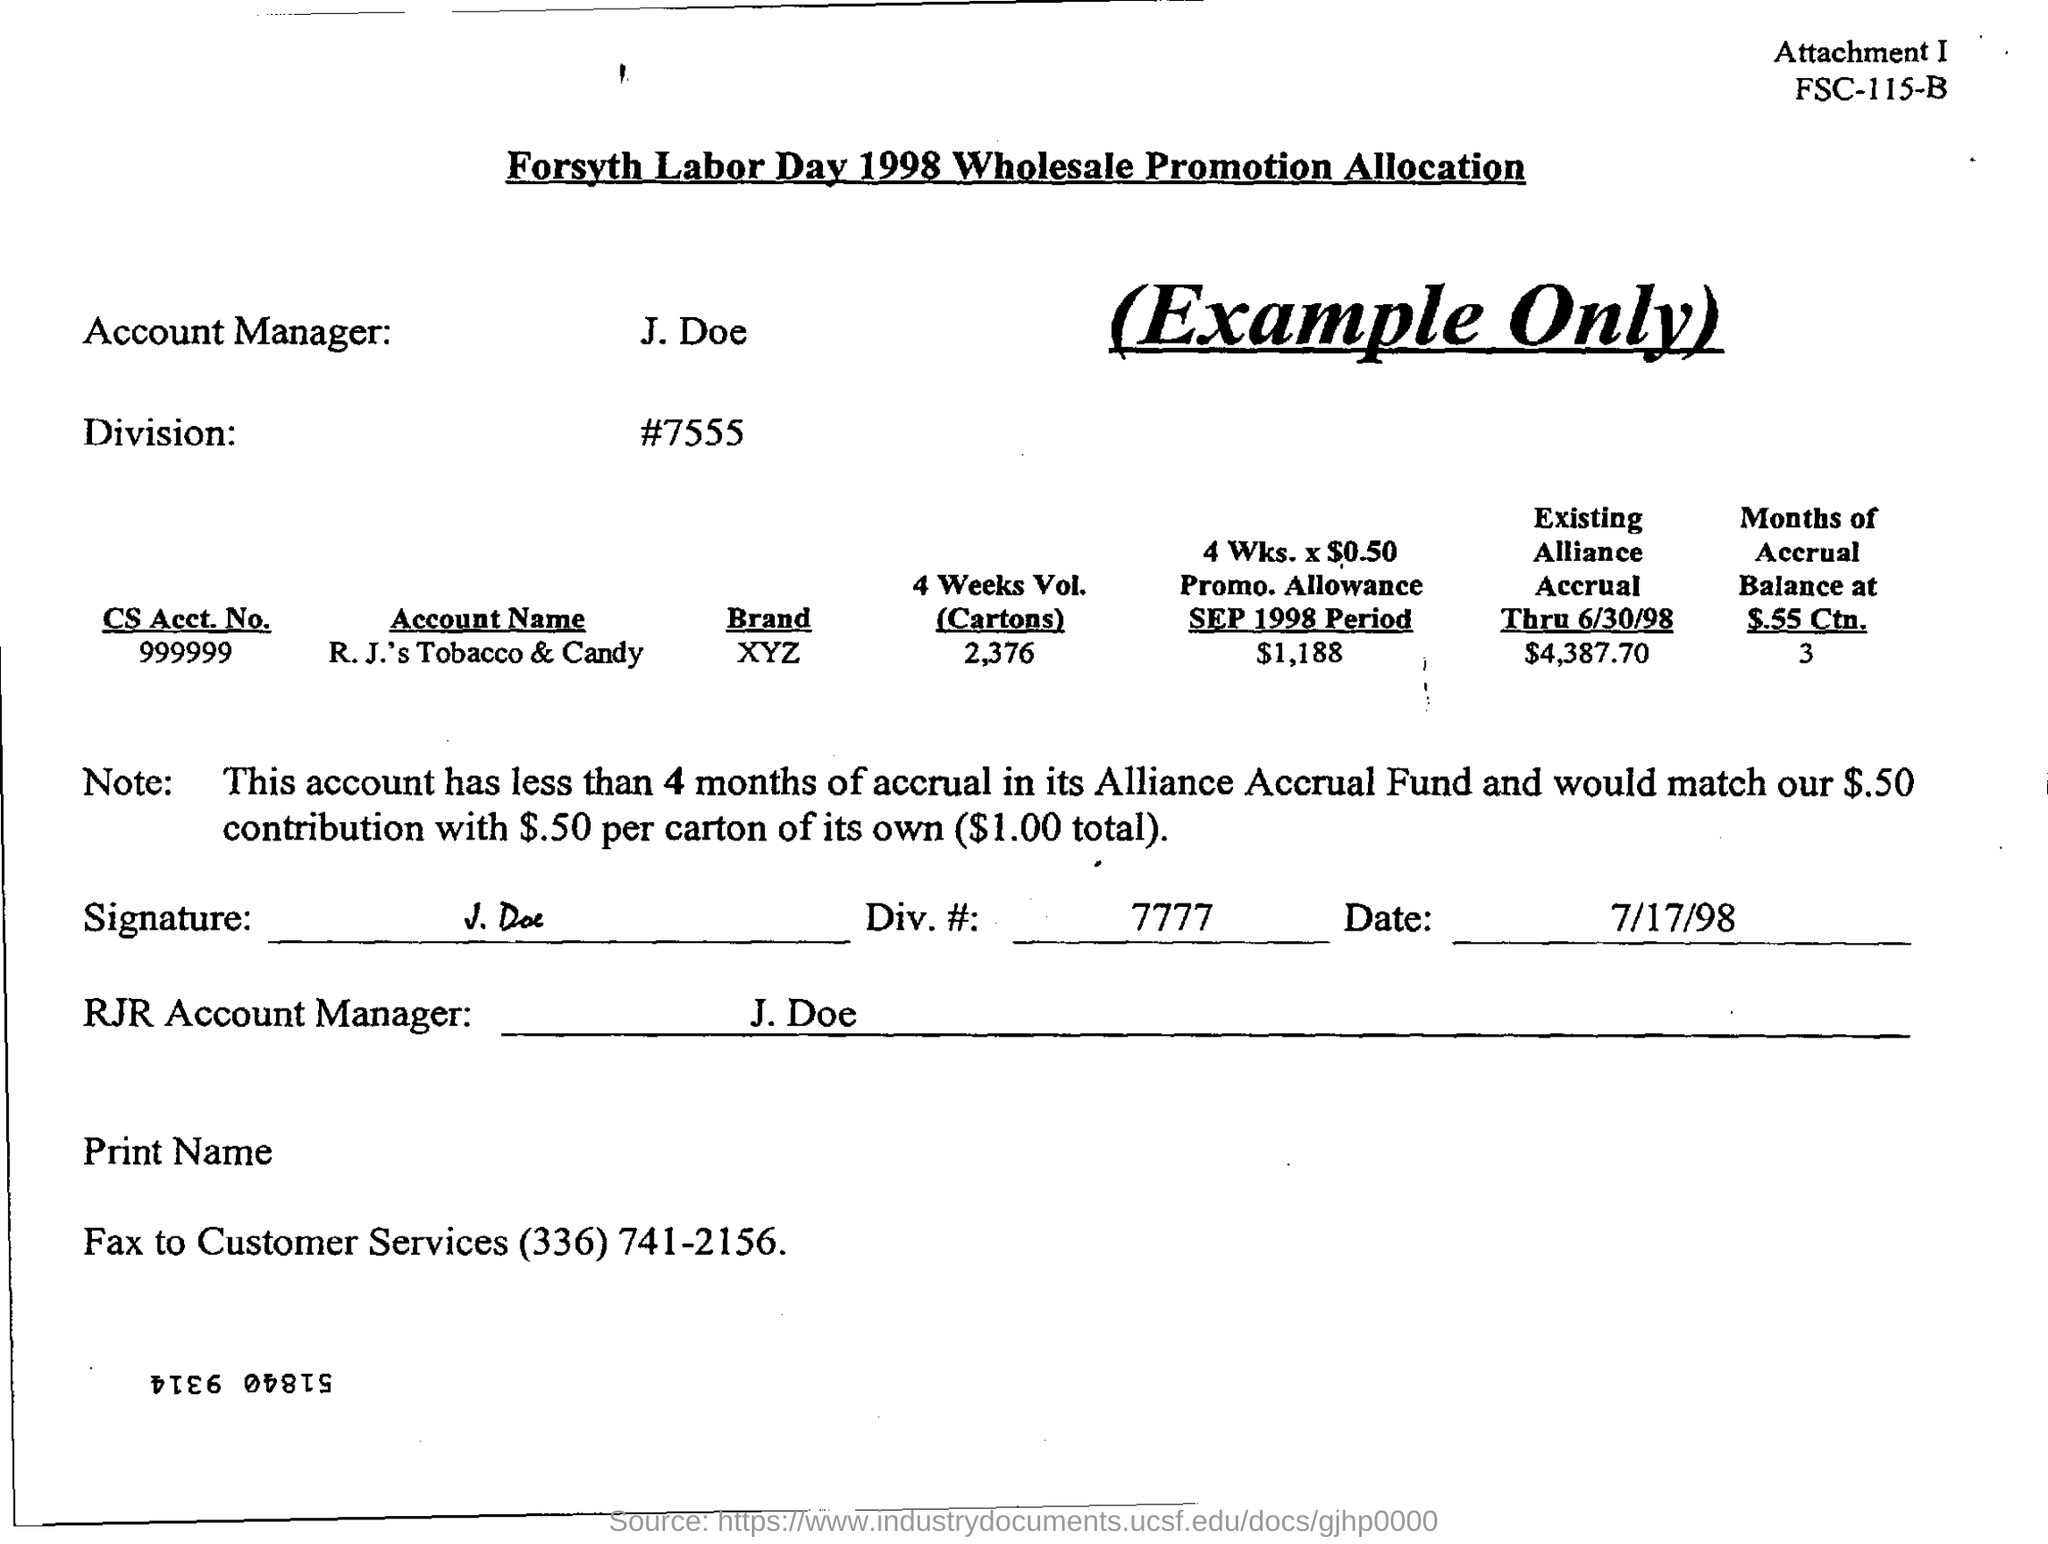Indicate a few pertinent items in this graphic. The fax number for customer services is (336) 741-2156. The person who is the account manager is named J. Doe. This account has less than 4 months of accrual in its Alliance Accrual Fund. The form is dated as of July 17, 1998. I request that the CS Acct. No. specified in the form be 999999... 